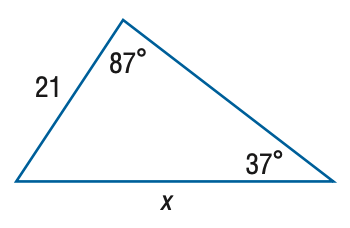Answer the mathemtical geometry problem and directly provide the correct option letter.
Question: Find x. Round the side measure to the nearest tenth.
Choices: A: 12.7 B: 15.2 C: 28.9 D: 34.8 D 